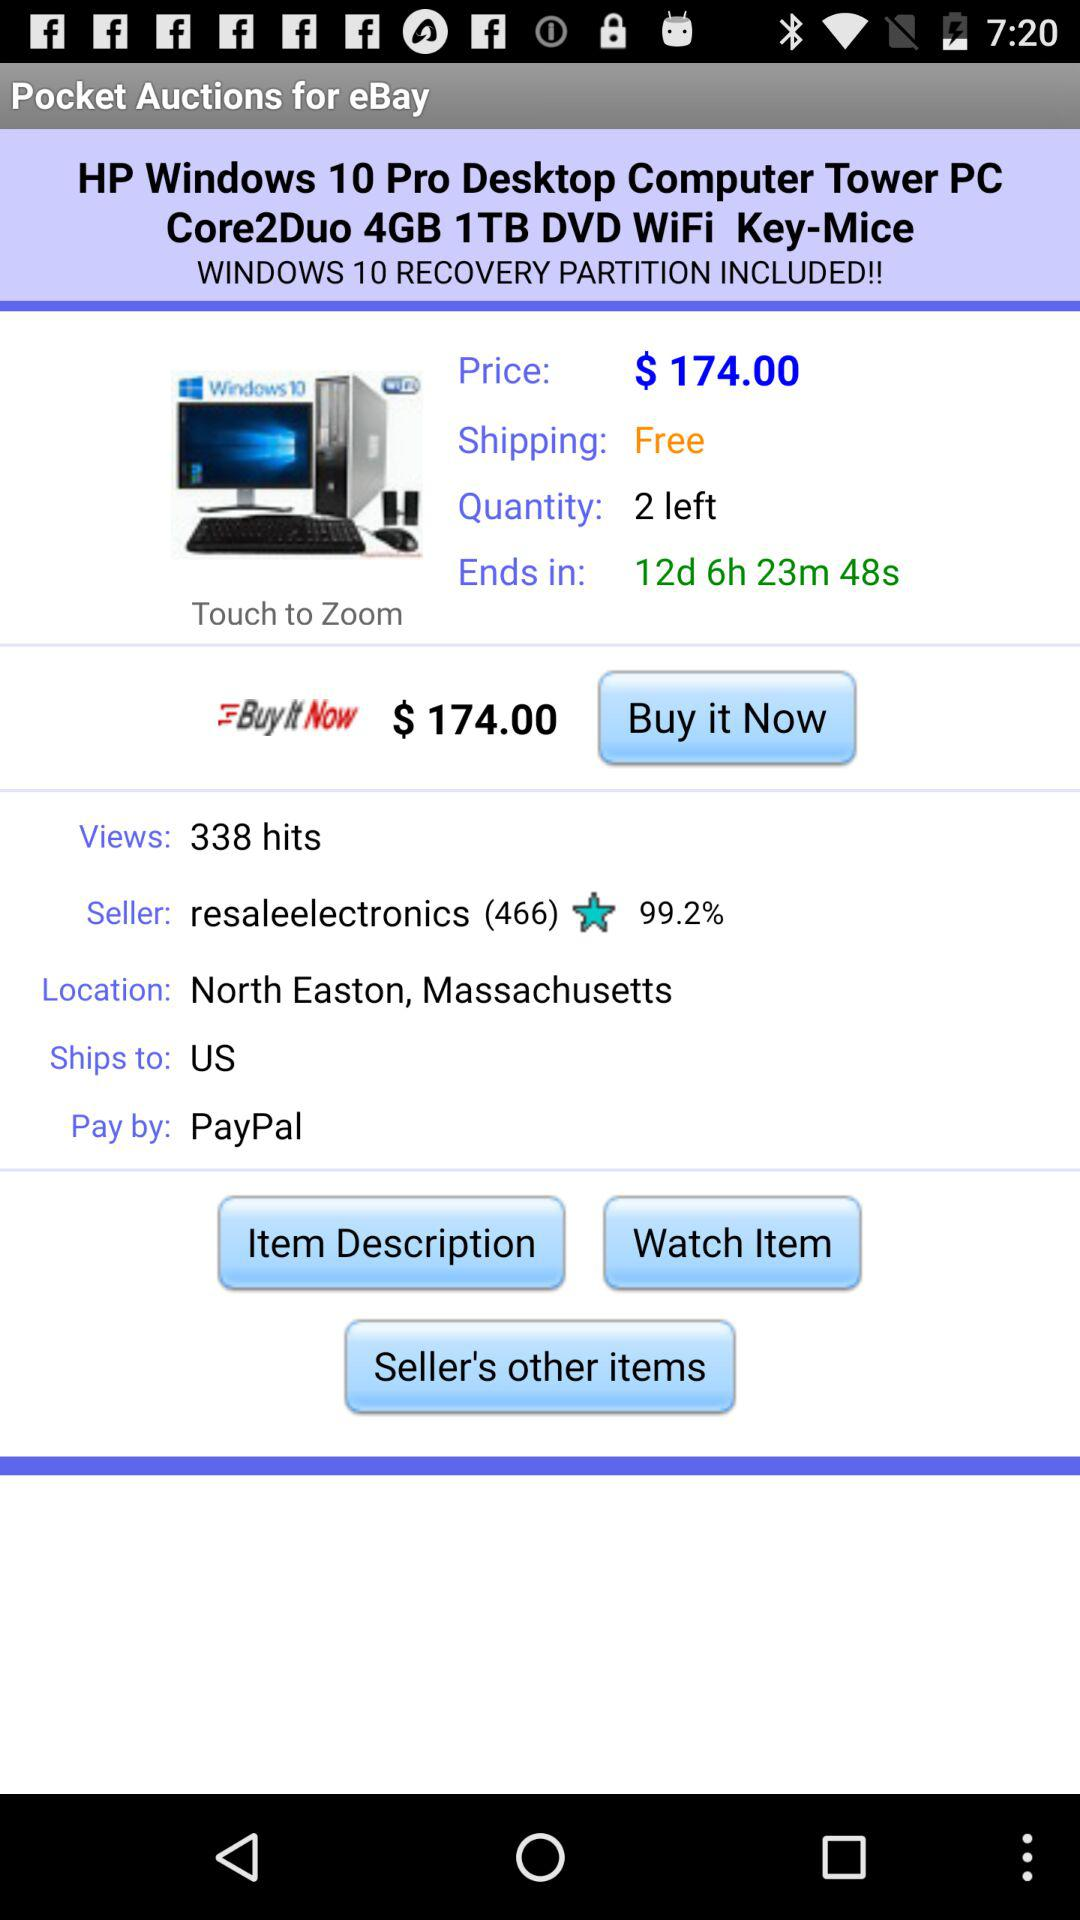What is the price of the "HP Windows 10 Pro Desktop Computer Tower PC"? The price is $174.00. 